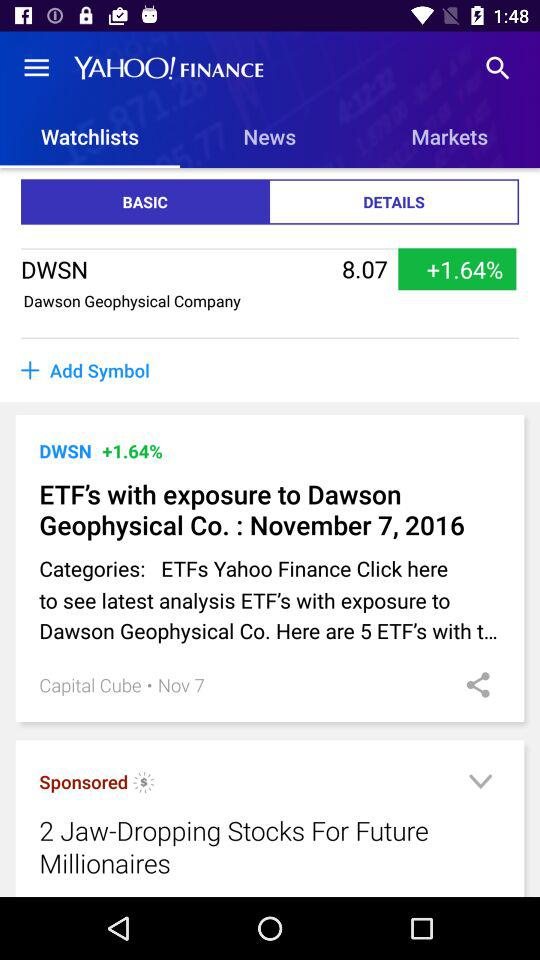Which tab has been selected? The selected tab is "BASIC". 